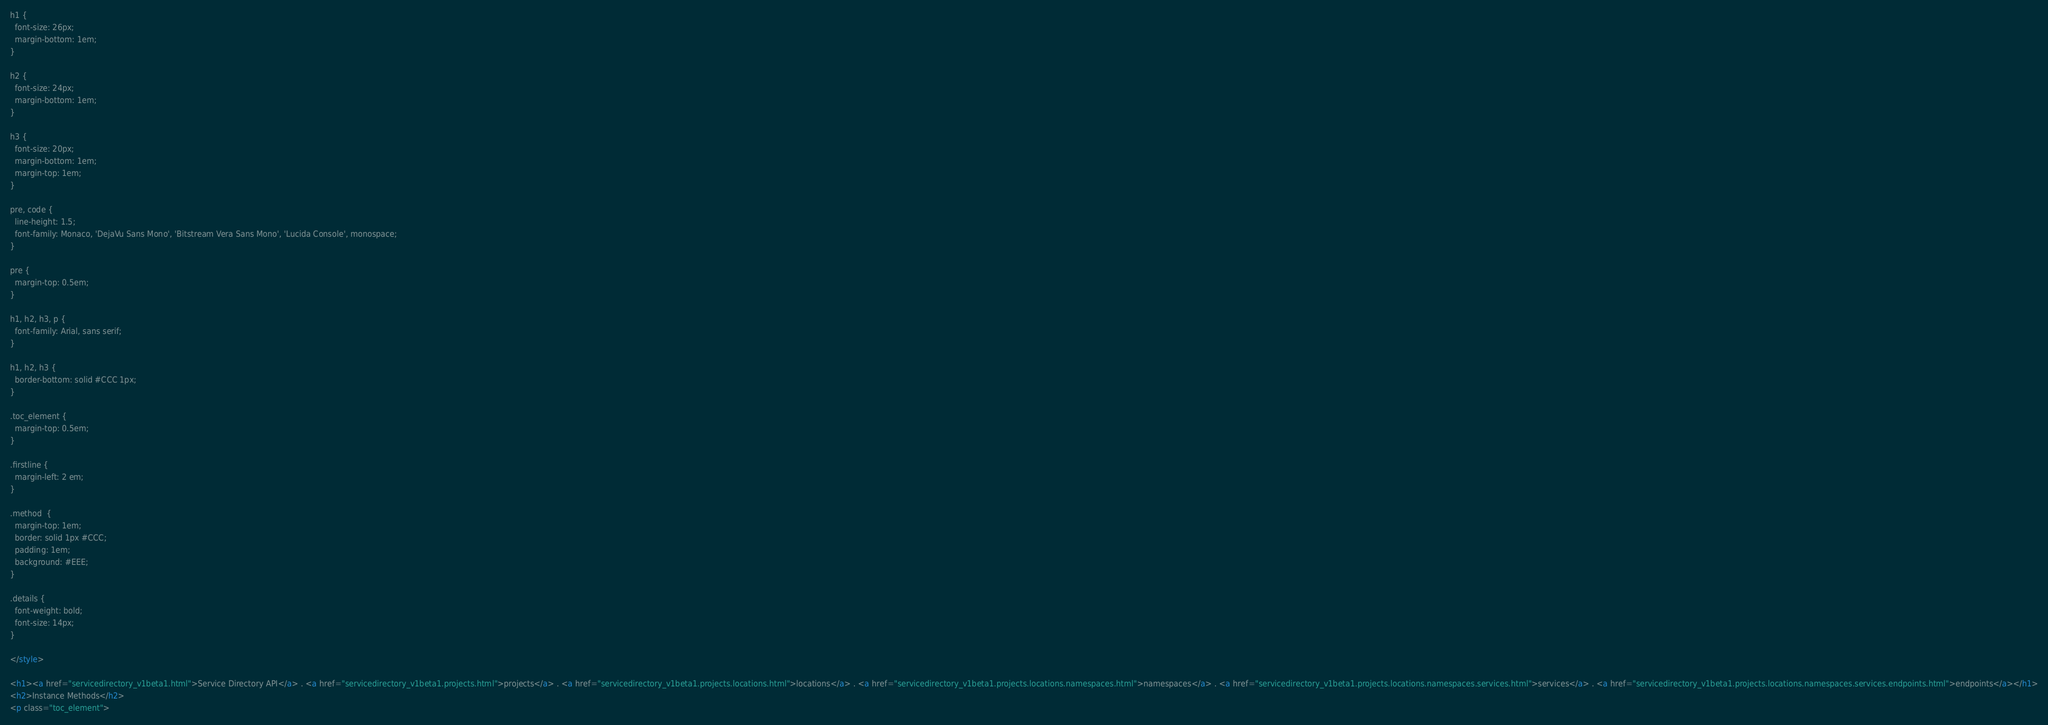Convert code to text. <code><loc_0><loc_0><loc_500><loc_500><_HTML_>
h1 {
  font-size: 26px;
  margin-bottom: 1em;
}

h2 {
  font-size: 24px;
  margin-bottom: 1em;
}

h3 {
  font-size: 20px;
  margin-bottom: 1em;
  margin-top: 1em;
}

pre, code {
  line-height: 1.5;
  font-family: Monaco, 'DejaVu Sans Mono', 'Bitstream Vera Sans Mono', 'Lucida Console', monospace;
}

pre {
  margin-top: 0.5em;
}

h1, h2, h3, p {
  font-family: Arial, sans serif;
}

h1, h2, h3 {
  border-bottom: solid #CCC 1px;
}

.toc_element {
  margin-top: 0.5em;
}

.firstline {
  margin-left: 2 em;
}

.method  {
  margin-top: 1em;
  border: solid 1px #CCC;
  padding: 1em;
  background: #EEE;
}

.details {
  font-weight: bold;
  font-size: 14px;
}

</style>

<h1><a href="servicedirectory_v1beta1.html">Service Directory API</a> . <a href="servicedirectory_v1beta1.projects.html">projects</a> . <a href="servicedirectory_v1beta1.projects.locations.html">locations</a> . <a href="servicedirectory_v1beta1.projects.locations.namespaces.html">namespaces</a> . <a href="servicedirectory_v1beta1.projects.locations.namespaces.services.html">services</a> . <a href="servicedirectory_v1beta1.projects.locations.namespaces.services.endpoints.html">endpoints</a></h1>
<h2>Instance Methods</h2>
<p class="toc_element"></code> 